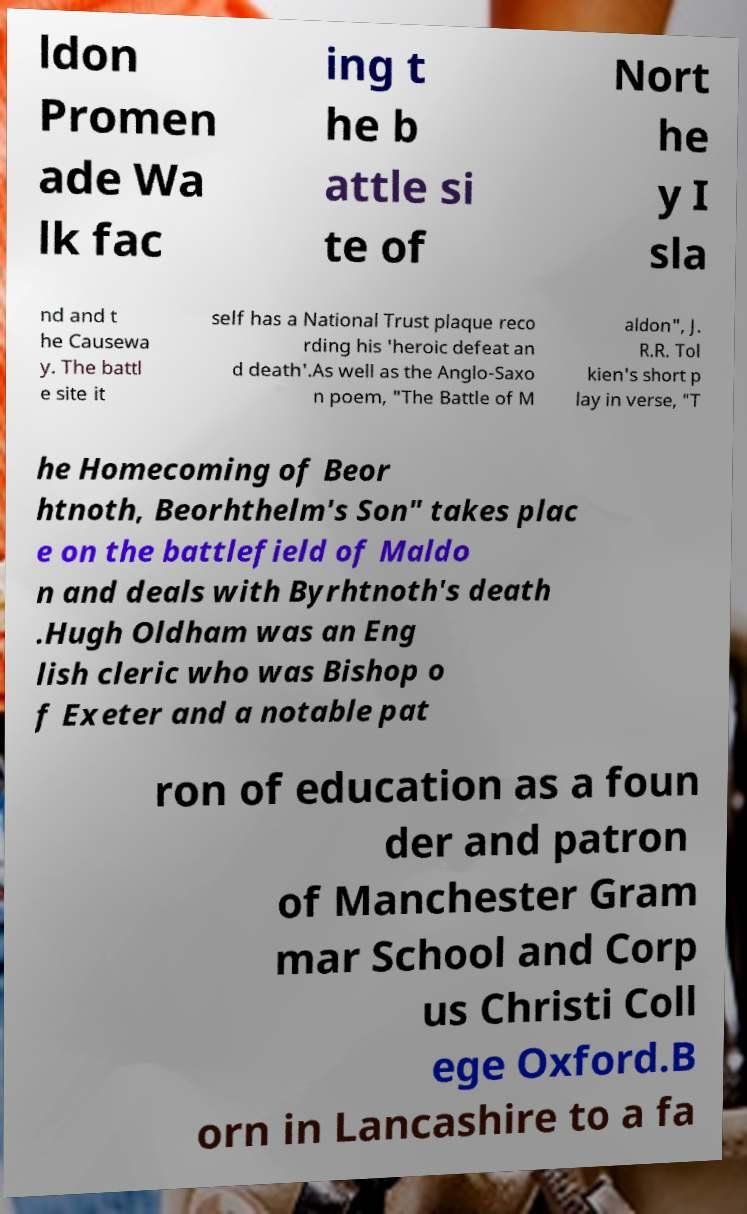I need the written content from this picture converted into text. Can you do that? ldon Promen ade Wa lk fac ing t he b attle si te of Nort he y I sla nd and t he Causewa y. The battl e site it self has a National Trust plaque reco rding his 'heroic defeat an d death'.As well as the Anglo-Saxo n poem, "The Battle of M aldon", J. R.R. Tol kien's short p lay in verse, "T he Homecoming of Beor htnoth, Beorhthelm's Son" takes plac e on the battlefield of Maldo n and deals with Byrhtnoth's death .Hugh Oldham was an Eng lish cleric who was Bishop o f Exeter and a notable pat ron of education as a foun der and patron of Manchester Gram mar School and Corp us Christi Coll ege Oxford.B orn in Lancashire to a fa 